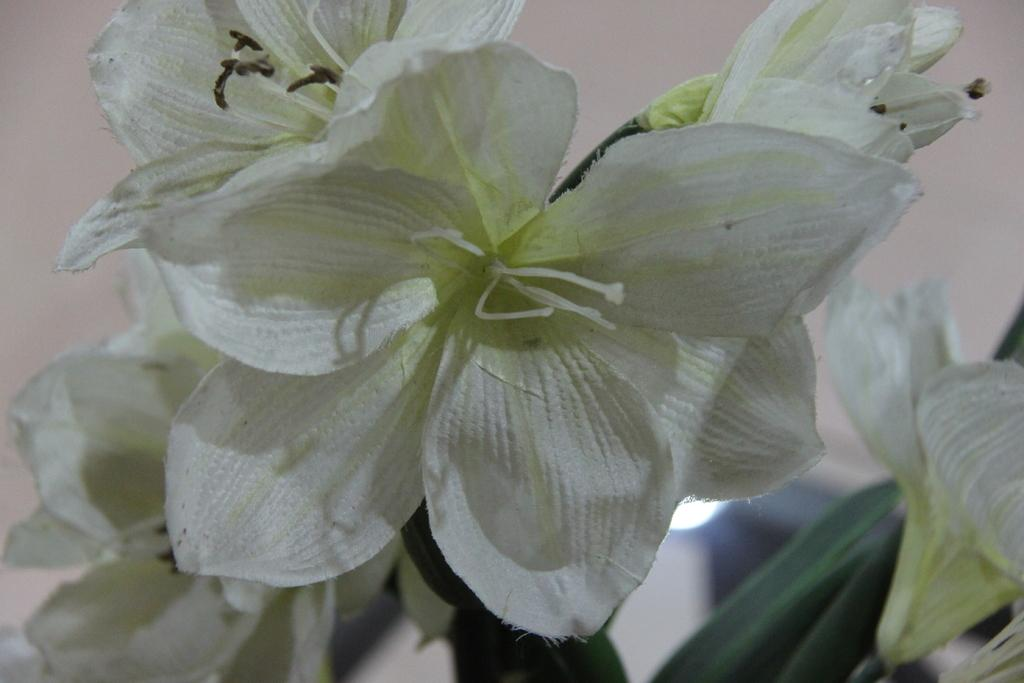What type of living organisms can be seen in the image? Flowers are visible in the image. What type of sound can be heard coming from the flowers in the image? There is no sound coming from the flowers in the image, as flowers do not produce sound. 